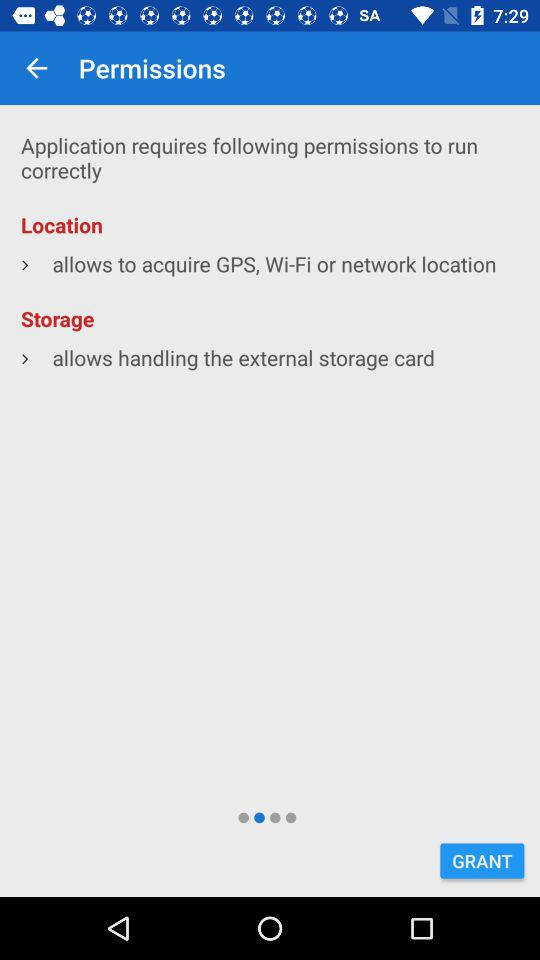How many permissions are required to run the application correctly?
Answer the question using a single word or phrase. 2 